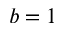Convert formula to latex. <formula><loc_0><loc_0><loc_500><loc_500>b = 1</formula> 